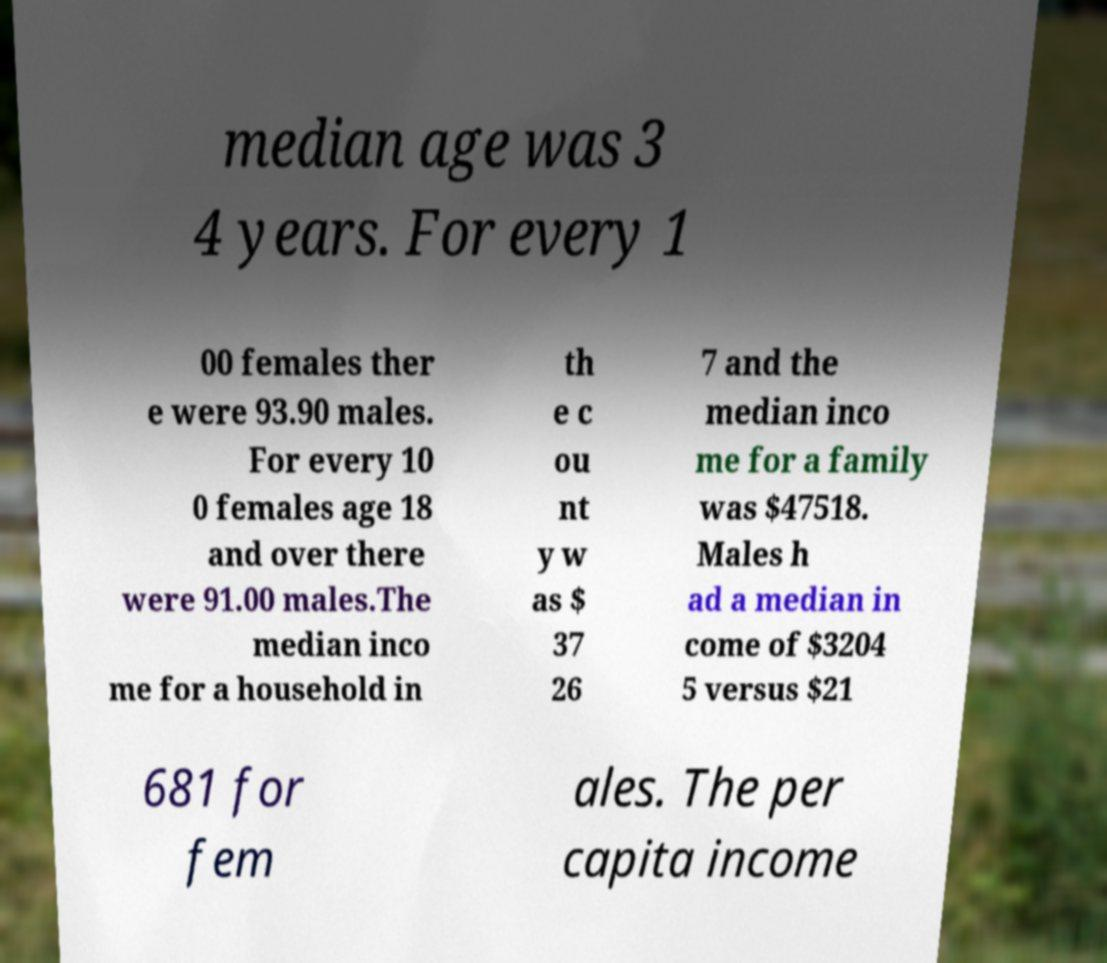I need the written content from this picture converted into text. Can you do that? median age was 3 4 years. For every 1 00 females ther e were 93.90 males. For every 10 0 females age 18 and over there were 91.00 males.The median inco me for a household in th e c ou nt y w as $ 37 26 7 and the median inco me for a family was $47518. Males h ad a median in come of $3204 5 versus $21 681 for fem ales. The per capita income 